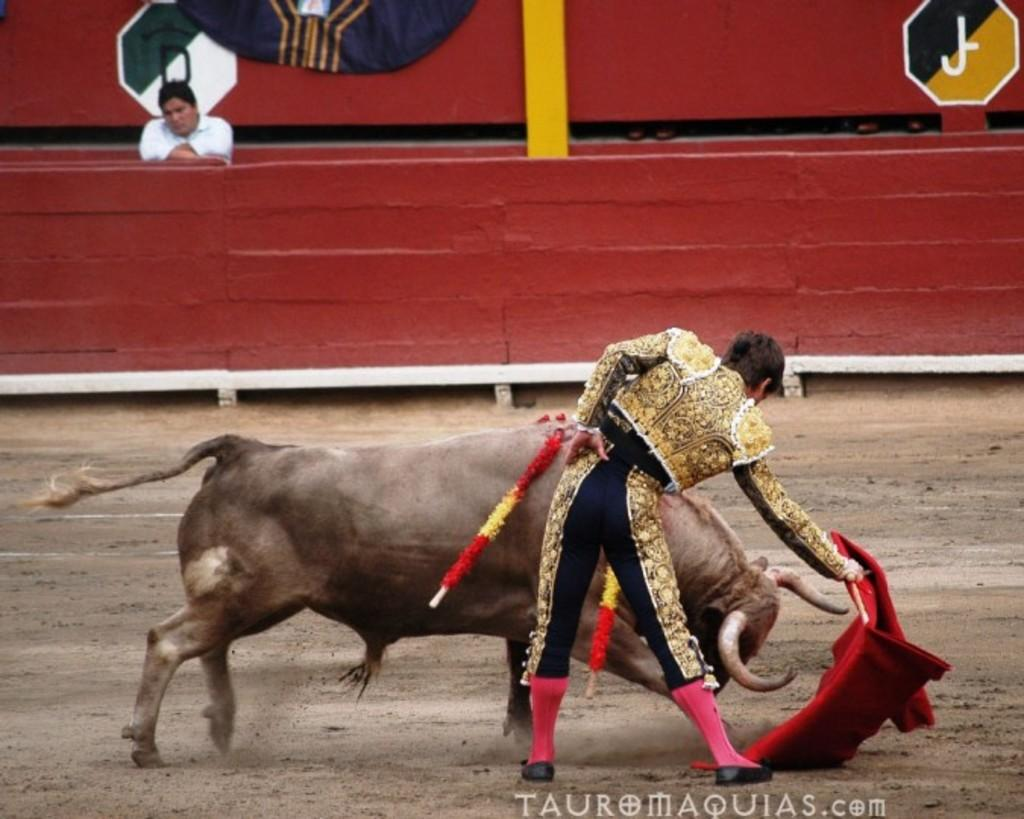What animal is present in the image? There is a bull in the image. Who is interacting with the bull in the image? There is a bullfighter in the image. What is the bullfighter holding? The bullfighter is holding a red cloth. What can be seen behind the bull? There is a wall behind the bull. What type of material is visible in the image? There are boards visible in the image. Are there any other people in the image besides the bullfighter? Yes, there is another person in the image. What type of voyage is the bull taking in the image? There is no voyage present in the image; it is a still image of a bull and a bullfighter. What is the carriage used for in the image? There is no carriage present in the image. How many toes can be seen on the bull's feet in the image? Bulls do not have toes; they have hooves, which are not visible in the image. 